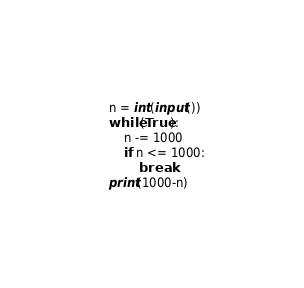<code> <loc_0><loc_0><loc_500><loc_500><_Python_>n = int(input())
while(True):
    n -= 1000
    if n <= 1000:
        break
print(1000-n)
</code> 